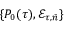<formula> <loc_0><loc_0><loc_500><loc_500>\{ P _ { 0 } ( \tau ) , \mathcal { E } _ { \tau , \bar { n } } \}</formula> 